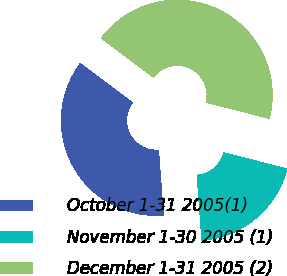Convert chart. <chart><loc_0><loc_0><loc_500><loc_500><pie_chart><fcel>October 1-31 2005(1)<fcel>November 1-30 2005 (1)<fcel>December 1-31 2005 (2)<nl><fcel>36.41%<fcel>19.88%<fcel>43.71%<nl></chart> 